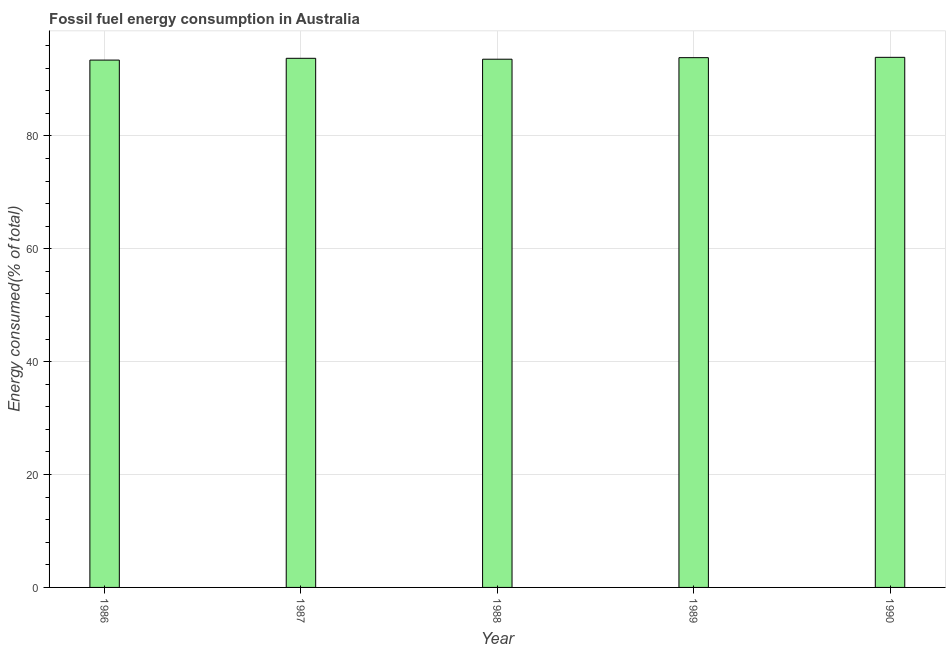What is the title of the graph?
Offer a terse response. Fossil fuel energy consumption in Australia. What is the label or title of the Y-axis?
Your answer should be very brief. Energy consumed(% of total). What is the fossil fuel energy consumption in 1986?
Give a very brief answer. 93.42. Across all years, what is the maximum fossil fuel energy consumption?
Give a very brief answer. 93.91. Across all years, what is the minimum fossil fuel energy consumption?
Keep it short and to the point. 93.42. In which year was the fossil fuel energy consumption maximum?
Your answer should be very brief. 1990. In which year was the fossil fuel energy consumption minimum?
Your answer should be very brief. 1986. What is the sum of the fossil fuel energy consumption?
Your answer should be very brief. 468.5. What is the difference between the fossil fuel energy consumption in 1989 and 1990?
Your response must be concise. -0.06. What is the average fossil fuel energy consumption per year?
Offer a terse response. 93.7. What is the median fossil fuel energy consumption?
Your answer should be compact. 93.74. In how many years, is the fossil fuel energy consumption greater than 52 %?
Your response must be concise. 5. What is the ratio of the fossil fuel energy consumption in 1987 to that in 1988?
Give a very brief answer. 1. Is the difference between the fossil fuel energy consumption in 1987 and 1989 greater than the difference between any two years?
Provide a succinct answer. No. What is the difference between the highest and the second highest fossil fuel energy consumption?
Make the answer very short. 0.06. Is the sum of the fossil fuel energy consumption in 1986 and 1988 greater than the maximum fossil fuel energy consumption across all years?
Your response must be concise. Yes. What is the difference between the highest and the lowest fossil fuel energy consumption?
Offer a terse response. 0.49. In how many years, is the fossil fuel energy consumption greater than the average fossil fuel energy consumption taken over all years?
Give a very brief answer. 3. How many years are there in the graph?
Make the answer very short. 5. Are the values on the major ticks of Y-axis written in scientific E-notation?
Your answer should be very brief. No. What is the Energy consumed(% of total) of 1986?
Make the answer very short. 93.42. What is the Energy consumed(% of total) in 1987?
Provide a short and direct response. 93.74. What is the Energy consumed(% of total) of 1988?
Provide a short and direct response. 93.58. What is the Energy consumed(% of total) in 1989?
Ensure brevity in your answer.  93.85. What is the Energy consumed(% of total) in 1990?
Provide a short and direct response. 93.91. What is the difference between the Energy consumed(% of total) in 1986 and 1987?
Make the answer very short. -0.32. What is the difference between the Energy consumed(% of total) in 1986 and 1988?
Offer a very short reply. -0.16. What is the difference between the Energy consumed(% of total) in 1986 and 1989?
Provide a succinct answer. -0.43. What is the difference between the Energy consumed(% of total) in 1986 and 1990?
Your answer should be compact. -0.49. What is the difference between the Energy consumed(% of total) in 1987 and 1988?
Your response must be concise. 0.16. What is the difference between the Energy consumed(% of total) in 1987 and 1989?
Your answer should be compact. -0.11. What is the difference between the Energy consumed(% of total) in 1987 and 1990?
Offer a very short reply. -0.17. What is the difference between the Energy consumed(% of total) in 1988 and 1989?
Ensure brevity in your answer.  -0.27. What is the difference between the Energy consumed(% of total) in 1988 and 1990?
Make the answer very short. -0.33. What is the difference between the Energy consumed(% of total) in 1989 and 1990?
Ensure brevity in your answer.  -0.06. What is the ratio of the Energy consumed(% of total) in 1986 to that in 1988?
Ensure brevity in your answer.  1. What is the ratio of the Energy consumed(% of total) in 1986 to that in 1989?
Your answer should be very brief. 0.99. What is the ratio of the Energy consumed(% of total) in 1986 to that in 1990?
Provide a succinct answer. 0.99. What is the ratio of the Energy consumed(% of total) in 1987 to that in 1990?
Give a very brief answer. 1. What is the ratio of the Energy consumed(% of total) in 1988 to that in 1989?
Offer a terse response. 1. What is the ratio of the Energy consumed(% of total) in 1988 to that in 1990?
Offer a very short reply. 1. 